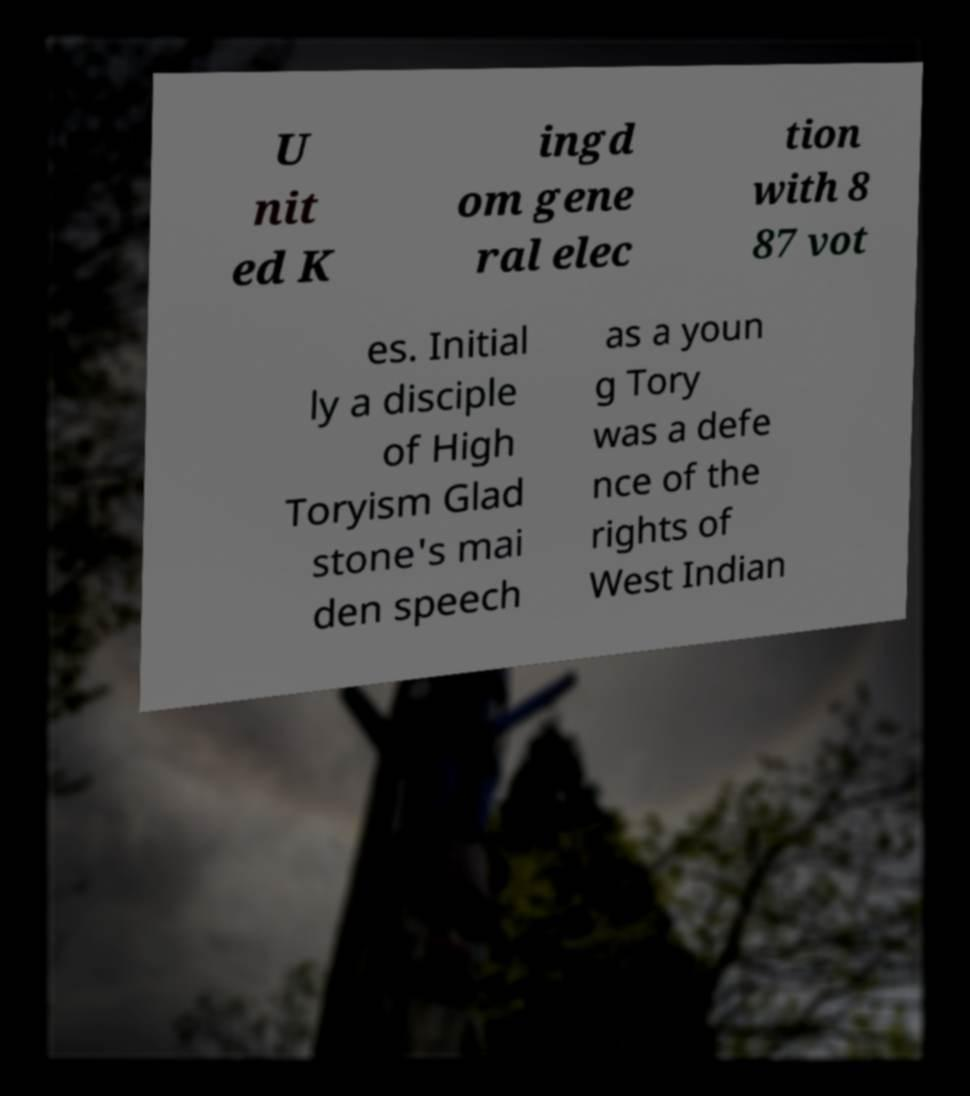Please read and relay the text visible in this image. What does it say? U nit ed K ingd om gene ral elec tion with 8 87 vot es. Initial ly a disciple of High Toryism Glad stone's mai den speech as a youn g Tory was a defe nce of the rights of West Indian 